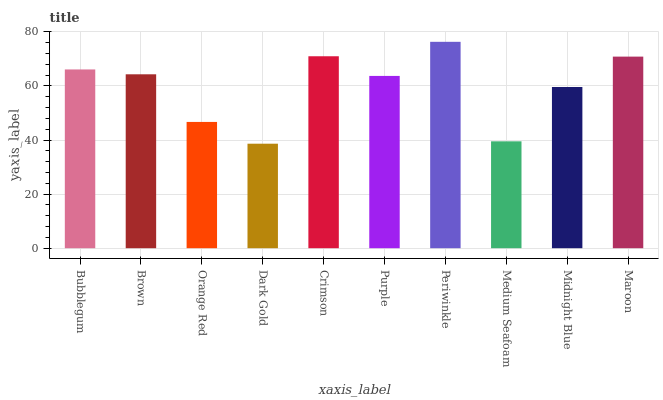Is Dark Gold the minimum?
Answer yes or no. Yes. Is Periwinkle the maximum?
Answer yes or no. Yes. Is Brown the minimum?
Answer yes or no. No. Is Brown the maximum?
Answer yes or no. No. Is Bubblegum greater than Brown?
Answer yes or no. Yes. Is Brown less than Bubblegum?
Answer yes or no. Yes. Is Brown greater than Bubblegum?
Answer yes or no. No. Is Bubblegum less than Brown?
Answer yes or no. No. Is Brown the high median?
Answer yes or no. Yes. Is Purple the low median?
Answer yes or no. Yes. Is Medium Seafoam the high median?
Answer yes or no. No. Is Maroon the low median?
Answer yes or no. No. 